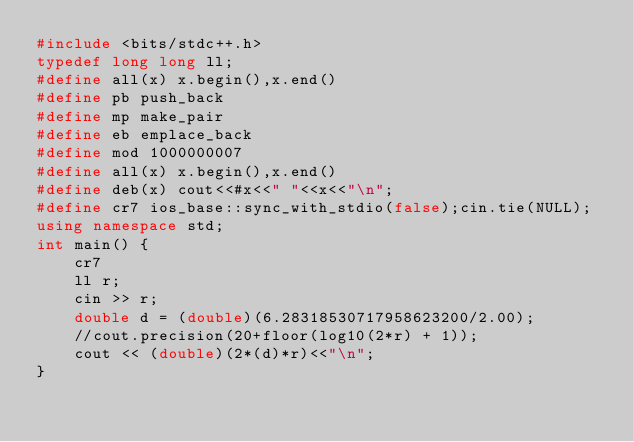Convert code to text. <code><loc_0><loc_0><loc_500><loc_500><_C++_>#include <bits/stdc++.h>
typedef long long ll;
#define all(x) x.begin(),x.end()
#define pb push_back
#define mp make_pair
#define eb emplace_back
#define mod 1000000007
#define all(x) x.begin(),x.end()
#define deb(x) cout<<#x<<" "<<x<<"\n";
#define cr7 ios_base::sync_with_stdio(false);cin.tie(NULL);
using namespace std;
int main() {
	cr7
	ll r;
	cin >> r;
	double d = (double)(6.28318530717958623200/2.00);
	//cout.precision(20+floor(log10(2*r) + 1));
	cout << (double)(2*(d)*r)<<"\n";
}</code> 